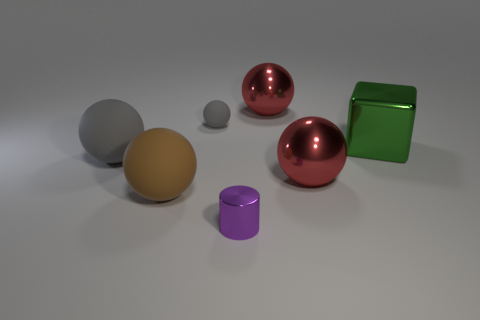How many things are either large brown things or large green cubes?
Keep it short and to the point. 2. There is a metal sphere behind the small object that is on the left side of the small purple cylinder; how many purple objects are behind it?
Ensure brevity in your answer.  0. Is there anything else that is the same color as the tiny matte sphere?
Provide a short and direct response. Yes. Is the color of the small thing behind the brown matte sphere the same as the large metallic object that is in front of the big green object?
Offer a terse response. No. Is the number of big brown things in front of the brown thing greater than the number of large spheres that are right of the tiny purple cylinder?
Offer a very short reply. No. What material is the purple cylinder?
Offer a very short reply. Metal. What shape is the tiny thing that is behind the gray matte object on the left side of the gray thing on the right side of the large brown thing?
Make the answer very short. Sphere. What number of other objects are the same material as the big gray thing?
Ensure brevity in your answer.  2. Are the small thing that is on the left side of the tiny purple shiny object and the big red object that is behind the large gray ball made of the same material?
Make the answer very short. No. How many things are behind the purple object and right of the tiny ball?
Offer a terse response. 3. 